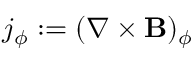<formula> <loc_0><loc_0><loc_500><loc_500>j _ { \phi } \colon = ( \nabla \times \mathbf B ) _ { \phi }</formula> 